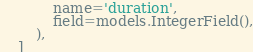<code> <loc_0><loc_0><loc_500><loc_500><_Python_>            name='duration',
            field=models.IntegerField(),
        ),
    ]
</code> 